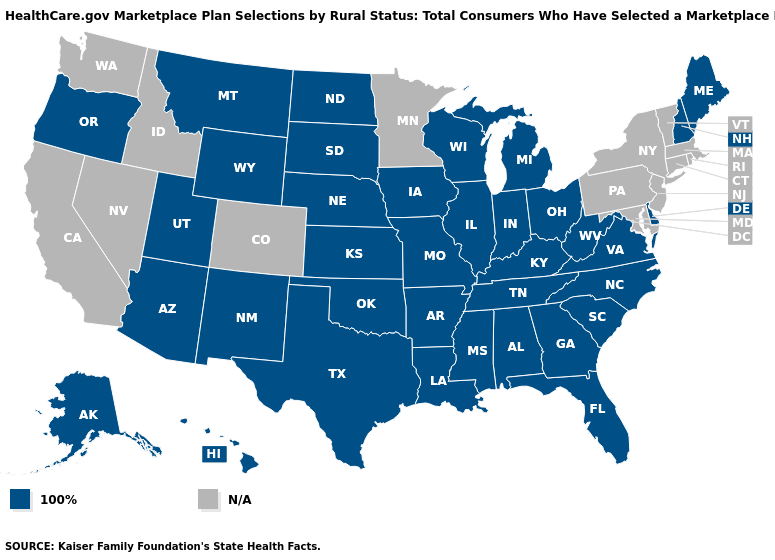Which states have the highest value in the USA?
Concise answer only. Alabama, Alaska, Arizona, Arkansas, Delaware, Florida, Georgia, Hawaii, Illinois, Indiana, Iowa, Kansas, Kentucky, Louisiana, Maine, Michigan, Mississippi, Missouri, Montana, Nebraska, New Hampshire, New Mexico, North Carolina, North Dakota, Ohio, Oklahoma, Oregon, South Carolina, South Dakota, Tennessee, Texas, Utah, Virginia, West Virginia, Wisconsin, Wyoming. What is the value of Alaska?
Short answer required. 100%. Name the states that have a value in the range 100%?
Concise answer only. Alabama, Alaska, Arizona, Arkansas, Delaware, Florida, Georgia, Hawaii, Illinois, Indiana, Iowa, Kansas, Kentucky, Louisiana, Maine, Michigan, Mississippi, Missouri, Montana, Nebraska, New Hampshire, New Mexico, North Carolina, North Dakota, Ohio, Oklahoma, Oregon, South Carolina, South Dakota, Tennessee, Texas, Utah, Virginia, West Virginia, Wisconsin, Wyoming. What is the value of West Virginia?
Be succinct. 100%. What is the lowest value in states that border Massachusetts?
Keep it brief. 100%. Name the states that have a value in the range N/A?
Short answer required. California, Colorado, Connecticut, Idaho, Maryland, Massachusetts, Minnesota, Nevada, New Jersey, New York, Pennsylvania, Rhode Island, Vermont, Washington. Name the states that have a value in the range 100%?
Keep it brief. Alabama, Alaska, Arizona, Arkansas, Delaware, Florida, Georgia, Hawaii, Illinois, Indiana, Iowa, Kansas, Kentucky, Louisiana, Maine, Michigan, Mississippi, Missouri, Montana, Nebraska, New Hampshire, New Mexico, North Carolina, North Dakota, Ohio, Oklahoma, Oregon, South Carolina, South Dakota, Tennessee, Texas, Utah, Virginia, West Virginia, Wisconsin, Wyoming. What is the value of Nevada?
Give a very brief answer. N/A. Name the states that have a value in the range 100%?
Write a very short answer. Alabama, Alaska, Arizona, Arkansas, Delaware, Florida, Georgia, Hawaii, Illinois, Indiana, Iowa, Kansas, Kentucky, Louisiana, Maine, Michigan, Mississippi, Missouri, Montana, Nebraska, New Hampshire, New Mexico, North Carolina, North Dakota, Ohio, Oklahoma, Oregon, South Carolina, South Dakota, Tennessee, Texas, Utah, Virginia, West Virginia, Wisconsin, Wyoming. Name the states that have a value in the range 100%?
Short answer required. Alabama, Alaska, Arizona, Arkansas, Delaware, Florida, Georgia, Hawaii, Illinois, Indiana, Iowa, Kansas, Kentucky, Louisiana, Maine, Michigan, Mississippi, Missouri, Montana, Nebraska, New Hampshire, New Mexico, North Carolina, North Dakota, Ohio, Oklahoma, Oregon, South Carolina, South Dakota, Tennessee, Texas, Utah, Virginia, West Virginia, Wisconsin, Wyoming. Which states have the lowest value in the MidWest?
Write a very short answer. Illinois, Indiana, Iowa, Kansas, Michigan, Missouri, Nebraska, North Dakota, Ohio, South Dakota, Wisconsin. Which states have the highest value in the USA?
Quick response, please. Alabama, Alaska, Arizona, Arkansas, Delaware, Florida, Georgia, Hawaii, Illinois, Indiana, Iowa, Kansas, Kentucky, Louisiana, Maine, Michigan, Mississippi, Missouri, Montana, Nebraska, New Hampshire, New Mexico, North Carolina, North Dakota, Ohio, Oklahoma, Oregon, South Carolina, South Dakota, Tennessee, Texas, Utah, Virginia, West Virginia, Wisconsin, Wyoming. 